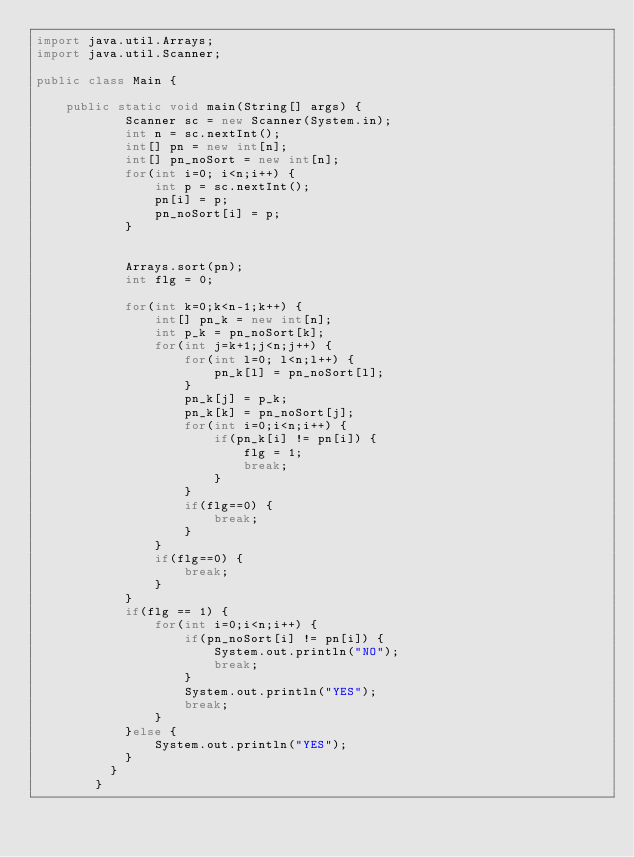Convert code to text. <code><loc_0><loc_0><loc_500><loc_500><_Java_>import java.util.Arrays;
import java.util.Scanner;

public class Main {

	public static void main(String[] args) {
		    Scanner sc = new Scanner(System.in);
		    int n = sc.nextInt();
		    int[] pn = new int[n];
		    int[] pn_noSort = new int[n];
		    for(int i=0; i<n;i++) {
		    	int p = sc.nextInt();
		    	pn[i] = p;
		    	pn_noSort[i] = p;
		    }


		    Arrays.sort(pn);
		    int flg = 0;

		    for(int k=0;k<n-1;k++) {
		    	int[] pn_k = new int[n];
		    	int p_k = pn_noSort[k];
		    	for(int j=k+1;j<n;j++) {
		    		for(int l=0; l<n;l++) {
			    		pn_k[l] = pn_noSort[l];
			    	}
		    		pn_k[j] = p_k;
		    		pn_k[k] = pn_noSort[j];
		    		for(int i=0;i<n;i++) {
		    			if(pn_k[i] != pn[i]) {
		    				flg = 1;
		    				break;
		    			}
		    		}
		    		if(flg==0) {
		    			break;
		    		}
		    	}
		    	if(flg==0) {
		    		break;
		    	}
		    }
		    if(flg == 1) {
		    	for(int i=0;i<n;i++) {
	    			if(pn_noSort[i] != pn[i]) {
	    				System.out.println("NO");
	    				break;
	    			}
	    			System.out.println("YES");
	    			break;
	    		}
		    }else {
		    	System.out.println("YES");
		    }
		  }
		}
</code> 